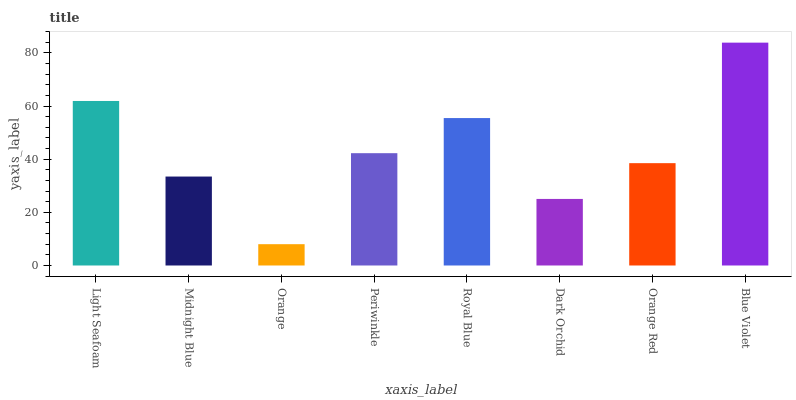Is Orange the minimum?
Answer yes or no. Yes. Is Blue Violet the maximum?
Answer yes or no. Yes. Is Midnight Blue the minimum?
Answer yes or no. No. Is Midnight Blue the maximum?
Answer yes or no. No. Is Light Seafoam greater than Midnight Blue?
Answer yes or no. Yes. Is Midnight Blue less than Light Seafoam?
Answer yes or no. Yes. Is Midnight Blue greater than Light Seafoam?
Answer yes or no. No. Is Light Seafoam less than Midnight Blue?
Answer yes or no. No. Is Periwinkle the high median?
Answer yes or no. Yes. Is Orange Red the low median?
Answer yes or no. Yes. Is Orange the high median?
Answer yes or no. No. Is Midnight Blue the low median?
Answer yes or no. No. 